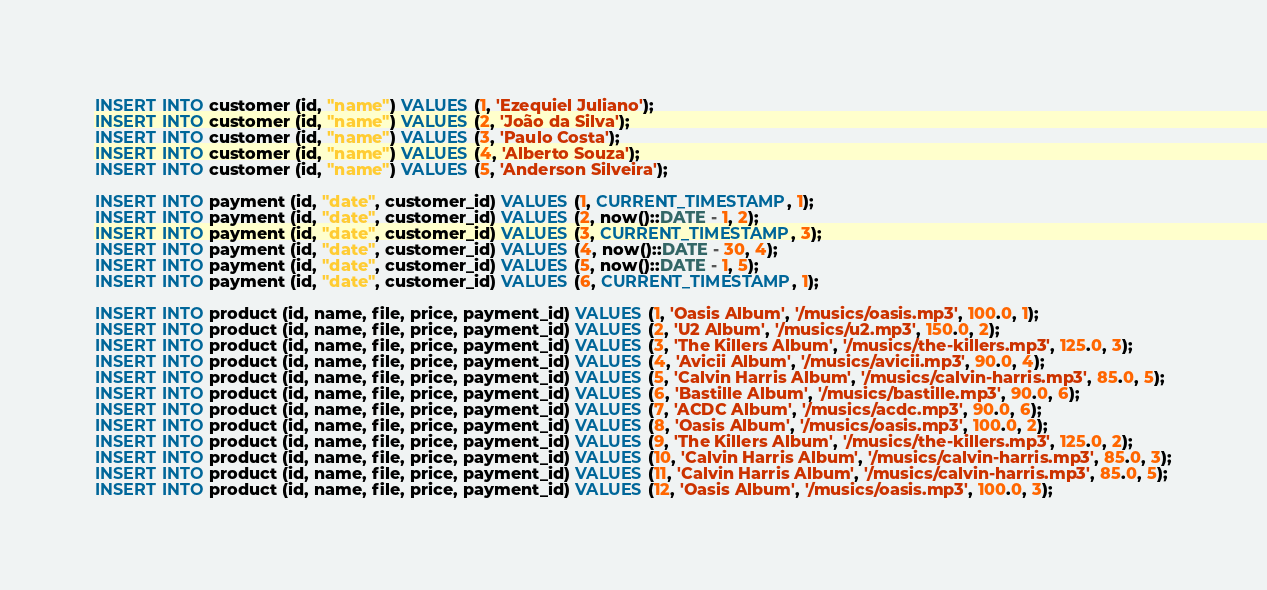<code> <loc_0><loc_0><loc_500><loc_500><_SQL_>INSERT INTO customer (id, "name") VALUES (1, 'Ezequiel Juliano');
INSERT INTO customer (id, "name") VALUES (2, 'João da Silva');
INSERT INTO customer (id, "name") VALUES (3, 'Paulo Costa');
INSERT INTO customer (id, "name") VALUES (4, 'Alberto Souza');
INSERT INTO customer (id, "name") VALUES (5, 'Anderson Silveira');

INSERT INTO payment (id, "date", customer_id) VALUES (1, CURRENT_TIMESTAMP, 1);
INSERT INTO payment (id, "date", customer_id) VALUES (2, now()::DATE - 1, 2);
INSERT INTO payment (id, "date", customer_id) VALUES (3, CURRENT_TIMESTAMP, 3);
INSERT INTO payment (id, "date", customer_id) VALUES (4, now()::DATE - 30, 4);
INSERT INTO payment (id, "date", customer_id) VALUES (5, now()::DATE - 1, 5);
INSERT INTO payment (id, "date", customer_id) VALUES (6, CURRENT_TIMESTAMP, 1);

INSERT INTO product (id, name, file, price, payment_id) VALUES (1, 'Oasis Album', '/musics/oasis.mp3', 100.0, 1);
INSERT INTO product (id, name, file, price, payment_id) VALUES (2, 'U2 Album', '/musics/u2.mp3', 150.0, 2);
INSERT INTO product (id, name, file, price, payment_id) VALUES (3, 'The Killers Album', '/musics/the-killers.mp3', 125.0, 3);
INSERT INTO product (id, name, file, price, payment_id) VALUES (4, 'Avicii Album', '/musics/avicii.mp3', 90.0, 4);
INSERT INTO product (id, name, file, price, payment_id) VALUES (5, 'Calvin Harris Album', '/musics/calvin-harris.mp3', 85.0, 5);
INSERT INTO product (id, name, file, price, payment_id) VALUES (6, 'Bastille Album', '/musics/bastille.mp3', 90.0, 6);
INSERT INTO product (id, name, file, price, payment_id) VALUES (7, 'ACDC Album', '/musics/acdc.mp3', 90.0, 6);
INSERT INTO product (id, name, file, price, payment_id) VALUES (8, 'Oasis Album', '/musics/oasis.mp3', 100.0, 2);
INSERT INTO product (id, name, file, price, payment_id) VALUES (9, 'The Killers Album', '/musics/the-killers.mp3', 125.0, 2);
INSERT INTO product (id, name, file, price, payment_id) VALUES (10, 'Calvin Harris Album', '/musics/calvin-harris.mp3', 85.0, 3);
INSERT INTO product (id, name, file, price, payment_id) VALUES (11, 'Calvin Harris Album', '/musics/calvin-harris.mp3', 85.0, 5);
INSERT INTO product (id, name, file, price, payment_id) VALUES (12, 'Oasis Album', '/musics/oasis.mp3', 100.0, 3);</code> 